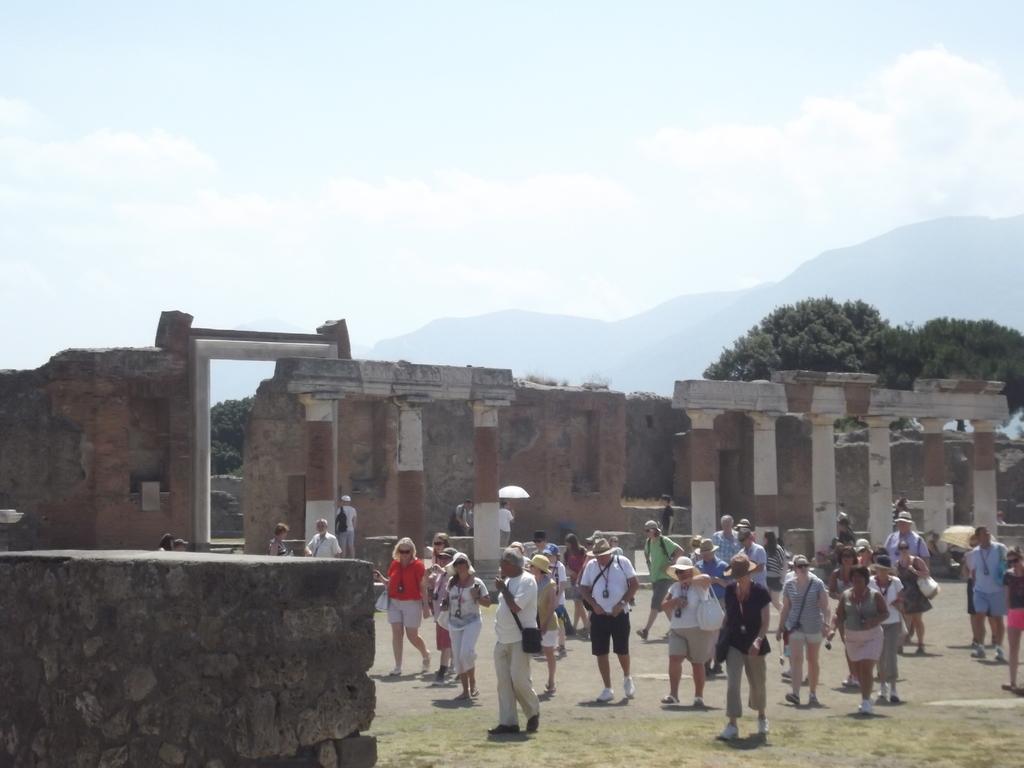How would you summarize this image in a sentence or two? In the image it looks like some ancient architecture and there are pillars and behind the pillars there is a wall, behind the wall there are many trees and there are a group of people standing in the front. 